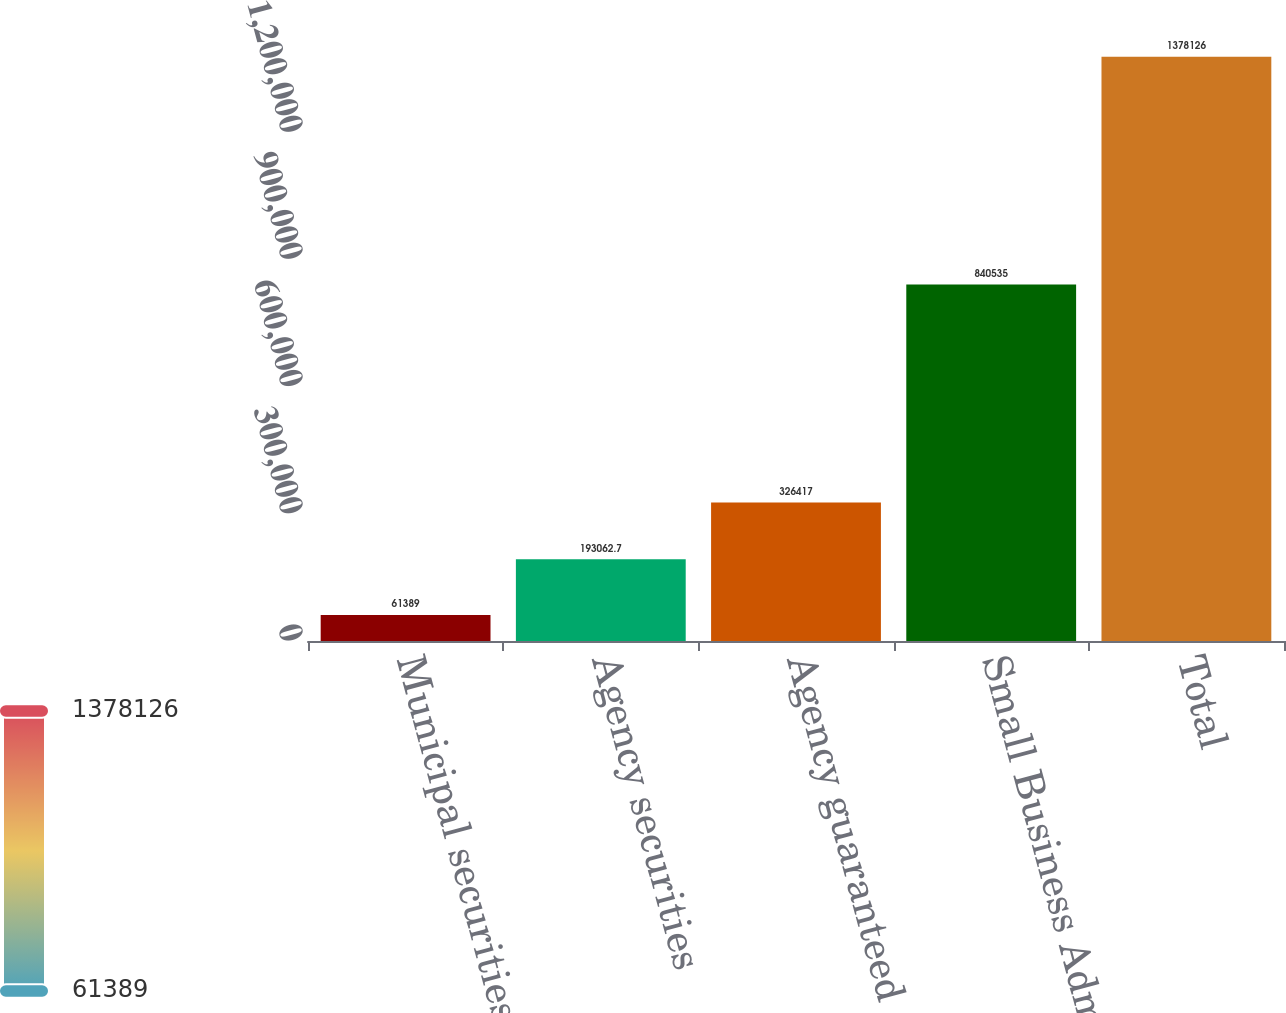Convert chart. <chart><loc_0><loc_0><loc_500><loc_500><bar_chart><fcel>Municipal securities<fcel>Agency securities<fcel>Agency guaranteed<fcel>Small Business Administration<fcel>Total<nl><fcel>61389<fcel>193063<fcel>326417<fcel>840535<fcel>1.37813e+06<nl></chart> 